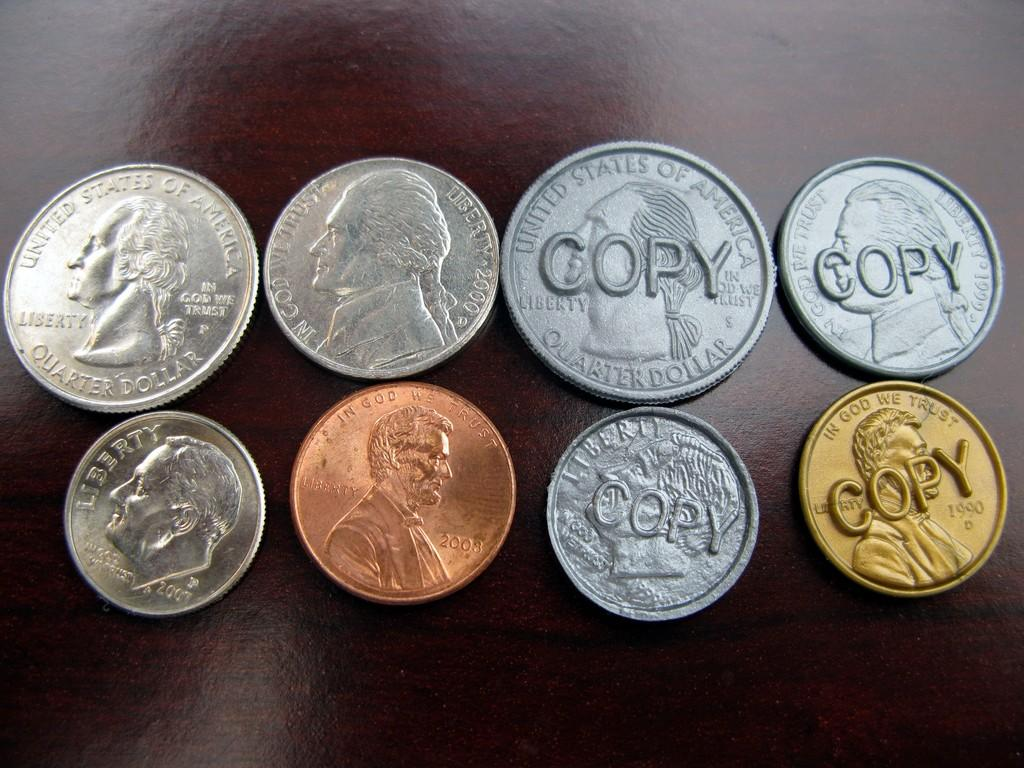<image>
Present a compact description of the photo's key features. Various US coins are displayed and COPY is in front of four of them. 